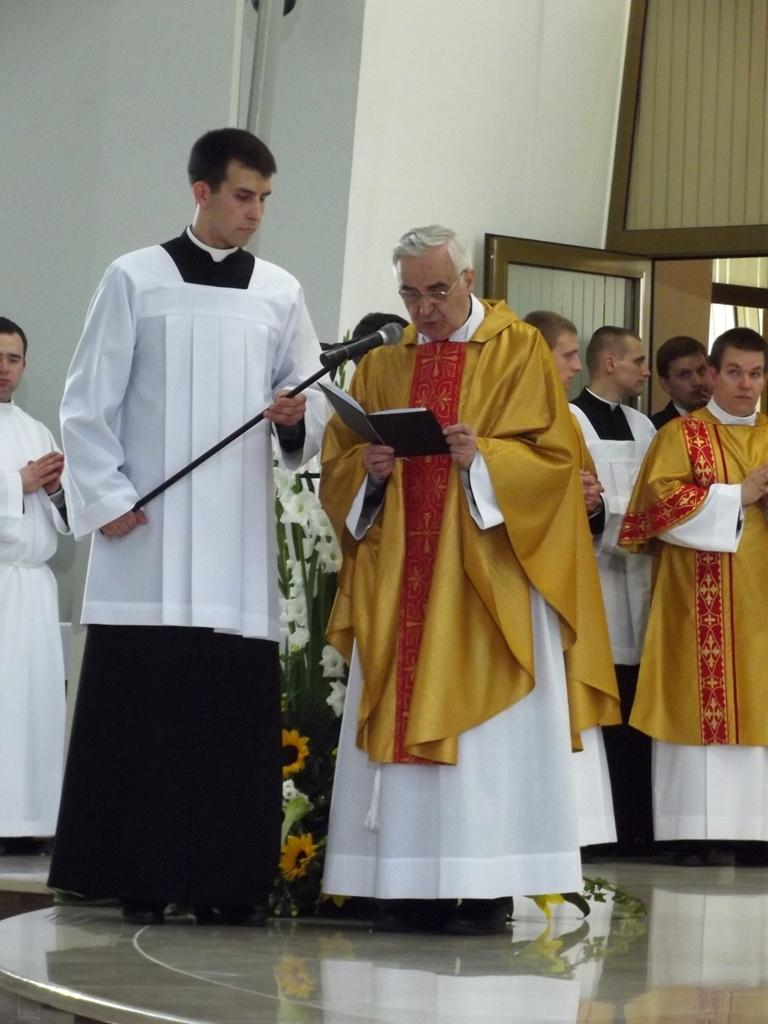What are the people in the image doing? The people in the image are standing in the middle of the image. What are the people holding in their hands? The people are holding something in their hands. What type of vegetation can be seen in the image? There are flowers and plants visible in the image. What architectural features can be seen at the top of the image? There is a wall and a door at the top of the image. What type of rifle can be seen leaning against the wall in the image? There is no rifle present in the image; only people, flowers, plants, a wall, and a door are visible. How much salt is visible on the plants in the image? There is no salt visible on the plants in the image, as the image only features people, flowers, plants, a wall, and a door. 